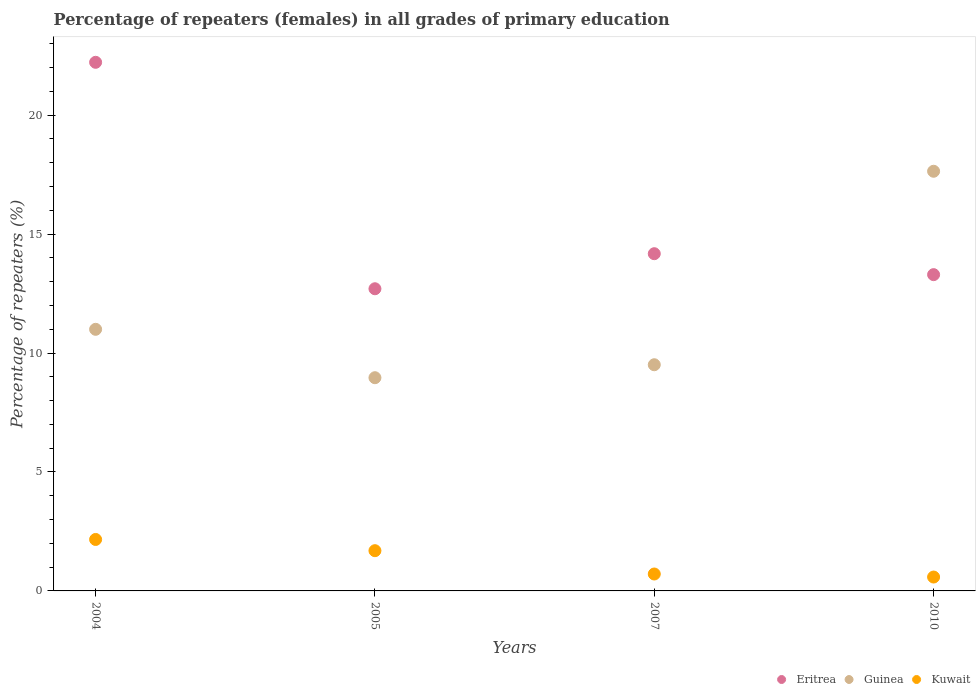How many different coloured dotlines are there?
Provide a short and direct response. 3. Is the number of dotlines equal to the number of legend labels?
Ensure brevity in your answer.  Yes. What is the percentage of repeaters (females) in Kuwait in 2004?
Provide a short and direct response. 2.16. Across all years, what is the maximum percentage of repeaters (females) in Eritrea?
Provide a short and direct response. 22.22. Across all years, what is the minimum percentage of repeaters (females) in Kuwait?
Offer a very short reply. 0.58. In which year was the percentage of repeaters (females) in Kuwait minimum?
Offer a very short reply. 2010. What is the total percentage of repeaters (females) in Guinea in the graph?
Give a very brief answer. 47.11. What is the difference between the percentage of repeaters (females) in Kuwait in 2005 and that in 2007?
Give a very brief answer. 0.98. What is the difference between the percentage of repeaters (females) in Kuwait in 2004 and the percentage of repeaters (females) in Guinea in 2005?
Provide a succinct answer. -6.8. What is the average percentage of repeaters (females) in Eritrea per year?
Provide a short and direct response. 15.6. In the year 2007, what is the difference between the percentage of repeaters (females) in Kuwait and percentage of repeaters (females) in Guinea?
Give a very brief answer. -8.8. In how many years, is the percentage of repeaters (females) in Guinea greater than 20 %?
Give a very brief answer. 0. What is the ratio of the percentage of repeaters (females) in Guinea in 2005 to that in 2007?
Offer a very short reply. 0.94. What is the difference between the highest and the second highest percentage of repeaters (females) in Eritrea?
Keep it short and to the point. 8.05. What is the difference between the highest and the lowest percentage of repeaters (females) in Eritrea?
Your response must be concise. 9.52. Is the sum of the percentage of repeaters (females) in Kuwait in 2005 and 2010 greater than the maximum percentage of repeaters (females) in Guinea across all years?
Offer a terse response. No. Does the percentage of repeaters (females) in Kuwait monotonically increase over the years?
Offer a terse response. No. Is the percentage of repeaters (females) in Eritrea strictly greater than the percentage of repeaters (females) in Guinea over the years?
Offer a very short reply. No. Is the percentage of repeaters (females) in Kuwait strictly less than the percentage of repeaters (females) in Eritrea over the years?
Provide a short and direct response. Yes. Are the values on the major ticks of Y-axis written in scientific E-notation?
Make the answer very short. No. How many legend labels are there?
Provide a succinct answer. 3. How are the legend labels stacked?
Your answer should be compact. Horizontal. What is the title of the graph?
Keep it short and to the point. Percentage of repeaters (females) in all grades of primary education. Does "West Bank and Gaza" appear as one of the legend labels in the graph?
Your answer should be compact. No. What is the label or title of the Y-axis?
Offer a terse response. Percentage of repeaters (%). What is the Percentage of repeaters (%) in Eritrea in 2004?
Ensure brevity in your answer.  22.22. What is the Percentage of repeaters (%) of Guinea in 2004?
Ensure brevity in your answer.  11. What is the Percentage of repeaters (%) of Kuwait in 2004?
Offer a very short reply. 2.16. What is the Percentage of repeaters (%) of Eritrea in 2005?
Provide a short and direct response. 12.7. What is the Percentage of repeaters (%) in Guinea in 2005?
Your answer should be very brief. 8.96. What is the Percentage of repeaters (%) of Kuwait in 2005?
Give a very brief answer. 1.69. What is the Percentage of repeaters (%) in Eritrea in 2007?
Give a very brief answer. 14.18. What is the Percentage of repeaters (%) in Guinea in 2007?
Your answer should be very brief. 9.51. What is the Percentage of repeaters (%) of Kuwait in 2007?
Offer a very short reply. 0.71. What is the Percentage of repeaters (%) of Eritrea in 2010?
Keep it short and to the point. 13.3. What is the Percentage of repeaters (%) of Guinea in 2010?
Keep it short and to the point. 17.64. What is the Percentage of repeaters (%) of Kuwait in 2010?
Your answer should be compact. 0.58. Across all years, what is the maximum Percentage of repeaters (%) of Eritrea?
Provide a succinct answer. 22.22. Across all years, what is the maximum Percentage of repeaters (%) in Guinea?
Give a very brief answer. 17.64. Across all years, what is the maximum Percentage of repeaters (%) in Kuwait?
Your answer should be very brief. 2.16. Across all years, what is the minimum Percentage of repeaters (%) of Eritrea?
Keep it short and to the point. 12.7. Across all years, what is the minimum Percentage of repeaters (%) in Guinea?
Make the answer very short. 8.96. Across all years, what is the minimum Percentage of repeaters (%) in Kuwait?
Your response must be concise. 0.58. What is the total Percentage of repeaters (%) of Eritrea in the graph?
Offer a terse response. 62.4. What is the total Percentage of repeaters (%) of Guinea in the graph?
Your answer should be very brief. 47.11. What is the total Percentage of repeaters (%) in Kuwait in the graph?
Ensure brevity in your answer.  5.15. What is the difference between the Percentage of repeaters (%) of Eritrea in 2004 and that in 2005?
Provide a succinct answer. 9.52. What is the difference between the Percentage of repeaters (%) of Guinea in 2004 and that in 2005?
Provide a succinct answer. 2.03. What is the difference between the Percentage of repeaters (%) of Kuwait in 2004 and that in 2005?
Provide a short and direct response. 0.47. What is the difference between the Percentage of repeaters (%) of Eritrea in 2004 and that in 2007?
Your answer should be compact. 8.05. What is the difference between the Percentage of repeaters (%) in Guinea in 2004 and that in 2007?
Make the answer very short. 1.49. What is the difference between the Percentage of repeaters (%) in Kuwait in 2004 and that in 2007?
Make the answer very short. 1.45. What is the difference between the Percentage of repeaters (%) in Eritrea in 2004 and that in 2010?
Your answer should be very brief. 8.93. What is the difference between the Percentage of repeaters (%) of Guinea in 2004 and that in 2010?
Offer a terse response. -6.64. What is the difference between the Percentage of repeaters (%) in Kuwait in 2004 and that in 2010?
Make the answer very short. 1.58. What is the difference between the Percentage of repeaters (%) in Eritrea in 2005 and that in 2007?
Make the answer very short. -1.47. What is the difference between the Percentage of repeaters (%) of Guinea in 2005 and that in 2007?
Make the answer very short. -0.55. What is the difference between the Percentage of repeaters (%) in Kuwait in 2005 and that in 2007?
Make the answer very short. 0.98. What is the difference between the Percentage of repeaters (%) in Eritrea in 2005 and that in 2010?
Offer a very short reply. -0.59. What is the difference between the Percentage of repeaters (%) of Guinea in 2005 and that in 2010?
Offer a terse response. -8.68. What is the difference between the Percentage of repeaters (%) of Kuwait in 2005 and that in 2010?
Make the answer very short. 1.11. What is the difference between the Percentage of repeaters (%) in Eritrea in 2007 and that in 2010?
Give a very brief answer. 0.88. What is the difference between the Percentage of repeaters (%) in Guinea in 2007 and that in 2010?
Make the answer very short. -8.13. What is the difference between the Percentage of repeaters (%) of Kuwait in 2007 and that in 2010?
Provide a succinct answer. 0.13. What is the difference between the Percentage of repeaters (%) in Eritrea in 2004 and the Percentage of repeaters (%) in Guinea in 2005?
Ensure brevity in your answer.  13.26. What is the difference between the Percentage of repeaters (%) in Eritrea in 2004 and the Percentage of repeaters (%) in Kuwait in 2005?
Provide a succinct answer. 20.53. What is the difference between the Percentage of repeaters (%) in Guinea in 2004 and the Percentage of repeaters (%) in Kuwait in 2005?
Ensure brevity in your answer.  9.31. What is the difference between the Percentage of repeaters (%) in Eritrea in 2004 and the Percentage of repeaters (%) in Guinea in 2007?
Offer a terse response. 12.71. What is the difference between the Percentage of repeaters (%) of Eritrea in 2004 and the Percentage of repeaters (%) of Kuwait in 2007?
Your answer should be very brief. 21.51. What is the difference between the Percentage of repeaters (%) in Guinea in 2004 and the Percentage of repeaters (%) in Kuwait in 2007?
Offer a terse response. 10.29. What is the difference between the Percentage of repeaters (%) in Eritrea in 2004 and the Percentage of repeaters (%) in Guinea in 2010?
Ensure brevity in your answer.  4.58. What is the difference between the Percentage of repeaters (%) of Eritrea in 2004 and the Percentage of repeaters (%) of Kuwait in 2010?
Give a very brief answer. 21.64. What is the difference between the Percentage of repeaters (%) in Guinea in 2004 and the Percentage of repeaters (%) in Kuwait in 2010?
Make the answer very short. 10.41. What is the difference between the Percentage of repeaters (%) of Eritrea in 2005 and the Percentage of repeaters (%) of Guinea in 2007?
Make the answer very short. 3.19. What is the difference between the Percentage of repeaters (%) in Eritrea in 2005 and the Percentage of repeaters (%) in Kuwait in 2007?
Provide a succinct answer. 11.99. What is the difference between the Percentage of repeaters (%) of Guinea in 2005 and the Percentage of repeaters (%) of Kuwait in 2007?
Keep it short and to the point. 8.25. What is the difference between the Percentage of repeaters (%) of Eritrea in 2005 and the Percentage of repeaters (%) of Guinea in 2010?
Offer a terse response. -4.94. What is the difference between the Percentage of repeaters (%) in Eritrea in 2005 and the Percentage of repeaters (%) in Kuwait in 2010?
Give a very brief answer. 12.12. What is the difference between the Percentage of repeaters (%) of Guinea in 2005 and the Percentage of repeaters (%) of Kuwait in 2010?
Offer a very short reply. 8.38. What is the difference between the Percentage of repeaters (%) of Eritrea in 2007 and the Percentage of repeaters (%) of Guinea in 2010?
Your response must be concise. -3.47. What is the difference between the Percentage of repeaters (%) of Eritrea in 2007 and the Percentage of repeaters (%) of Kuwait in 2010?
Keep it short and to the point. 13.59. What is the difference between the Percentage of repeaters (%) of Guinea in 2007 and the Percentage of repeaters (%) of Kuwait in 2010?
Make the answer very short. 8.93. What is the average Percentage of repeaters (%) of Eritrea per year?
Keep it short and to the point. 15.6. What is the average Percentage of repeaters (%) in Guinea per year?
Your answer should be very brief. 11.78. What is the average Percentage of repeaters (%) in Kuwait per year?
Offer a very short reply. 1.29. In the year 2004, what is the difference between the Percentage of repeaters (%) of Eritrea and Percentage of repeaters (%) of Guinea?
Your response must be concise. 11.22. In the year 2004, what is the difference between the Percentage of repeaters (%) of Eritrea and Percentage of repeaters (%) of Kuwait?
Ensure brevity in your answer.  20.06. In the year 2004, what is the difference between the Percentage of repeaters (%) of Guinea and Percentage of repeaters (%) of Kuwait?
Provide a short and direct response. 8.83. In the year 2005, what is the difference between the Percentage of repeaters (%) of Eritrea and Percentage of repeaters (%) of Guinea?
Your response must be concise. 3.74. In the year 2005, what is the difference between the Percentage of repeaters (%) of Eritrea and Percentage of repeaters (%) of Kuwait?
Ensure brevity in your answer.  11.01. In the year 2005, what is the difference between the Percentage of repeaters (%) of Guinea and Percentage of repeaters (%) of Kuwait?
Provide a succinct answer. 7.27. In the year 2007, what is the difference between the Percentage of repeaters (%) of Eritrea and Percentage of repeaters (%) of Guinea?
Your answer should be very brief. 4.67. In the year 2007, what is the difference between the Percentage of repeaters (%) of Eritrea and Percentage of repeaters (%) of Kuwait?
Keep it short and to the point. 13.47. In the year 2007, what is the difference between the Percentage of repeaters (%) in Guinea and Percentage of repeaters (%) in Kuwait?
Your answer should be compact. 8.8. In the year 2010, what is the difference between the Percentage of repeaters (%) of Eritrea and Percentage of repeaters (%) of Guinea?
Offer a terse response. -4.35. In the year 2010, what is the difference between the Percentage of repeaters (%) of Eritrea and Percentage of repeaters (%) of Kuwait?
Provide a succinct answer. 12.71. In the year 2010, what is the difference between the Percentage of repeaters (%) of Guinea and Percentage of repeaters (%) of Kuwait?
Your response must be concise. 17.06. What is the ratio of the Percentage of repeaters (%) of Eritrea in 2004 to that in 2005?
Keep it short and to the point. 1.75. What is the ratio of the Percentage of repeaters (%) of Guinea in 2004 to that in 2005?
Offer a terse response. 1.23. What is the ratio of the Percentage of repeaters (%) of Kuwait in 2004 to that in 2005?
Keep it short and to the point. 1.28. What is the ratio of the Percentage of repeaters (%) of Eritrea in 2004 to that in 2007?
Provide a succinct answer. 1.57. What is the ratio of the Percentage of repeaters (%) of Guinea in 2004 to that in 2007?
Your answer should be very brief. 1.16. What is the ratio of the Percentage of repeaters (%) of Kuwait in 2004 to that in 2007?
Offer a terse response. 3.04. What is the ratio of the Percentage of repeaters (%) in Eritrea in 2004 to that in 2010?
Provide a short and direct response. 1.67. What is the ratio of the Percentage of repeaters (%) in Guinea in 2004 to that in 2010?
Provide a short and direct response. 0.62. What is the ratio of the Percentage of repeaters (%) in Kuwait in 2004 to that in 2010?
Give a very brief answer. 3.71. What is the ratio of the Percentage of repeaters (%) of Eritrea in 2005 to that in 2007?
Make the answer very short. 0.9. What is the ratio of the Percentage of repeaters (%) of Guinea in 2005 to that in 2007?
Your answer should be compact. 0.94. What is the ratio of the Percentage of repeaters (%) of Kuwait in 2005 to that in 2007?
Provide a succinct answer. 2.38. What is the ratio of the Percentage of repeaters (%) in Eritrea in 2005 to that in 2010?
Offer a terse response. 0.96. What is the ratio of the Percentage of repeaters (%) in Guinea in 2005 to that in 2010?
Keep it short and to the point. 0.51. What is the ratio of the Percentage of repeaters (%) of Kuwait in 2005 to that in 2010?
Make the answer very short. 2.9. What is the ratio of the Percentage of repeaters (%) in Eritrea in 2007 to that in 2010?
Offer a very short reply. 1.07. What is the ratio of the Percentage of repeaters (%) in Guinea in 2007 to that in 2010?
Offer a very short reply. 0.54. What is the ratio of the Percentage of repeaters (%) in Kuwait in 2007 to that in 2010?
Ensure brevity in your answer.  1.22. What is the difference between the highest and the second highest Percentage of repeaters (%) of Eritrea?
Provide a succinct answer. 8.05. What is the difference between the highest and the second highest Percentage of repeaters (%) of Guinea?
Ensure brevity in your answer.  6.64. What is the difference between the highest and the second highest Percentage of repeaters (%) of Kuwait?
Offer a terse response. 0.47. What is the difference between the highest and the lowest Percentage of repeaters (%) in Eritrea?
Provide a short and direct response. 9.52. What is the difference between the highest and the lowest Percentage of repeaters (%) in Guinea?
Provide a succinct answer. 8.68. What is the difference between the highest and the lowest Percentage of repeaters (%) of Kuwait?
Give a very brief answer. 1.58. 